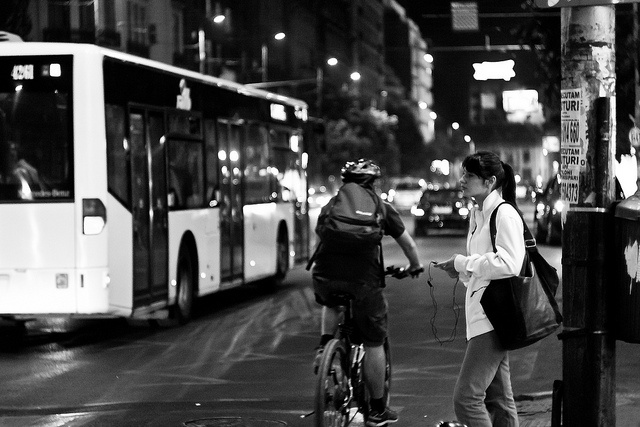Describe the objects in this image and their specific colors. I can see bus in black, lightgray, gray, and darkgray tones, people in black, gray, lightgray, and darkgray tones, people in black, gray, darkgray, and lightgray tones, handbag in black, gray, darkgray, and lightgray tones, and bicycle in black, gray, darkgray, and lightgray tones in this image. 